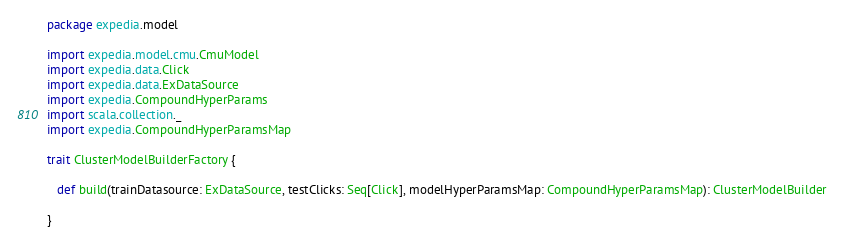<code> <loc_0><loc_0><loc_500><loc_500><_Scala_>package expedia.model

import expedia.model.cmu.CmuModel
import expedia.data.Click
import expedia.data.ExDataSource
import expedia.CompoundHyperParams
import scala.collection._
import expedia.CompoundHyperParamsMap

trait ClusterModelBuilderFactory {
  
   def build(trainDatasource: ExDataSource, testClicks: Seq[Click], modelHyperParamsMap: CompoundHyperParamsMap): ClusterModelBuilder
  
}</code> 